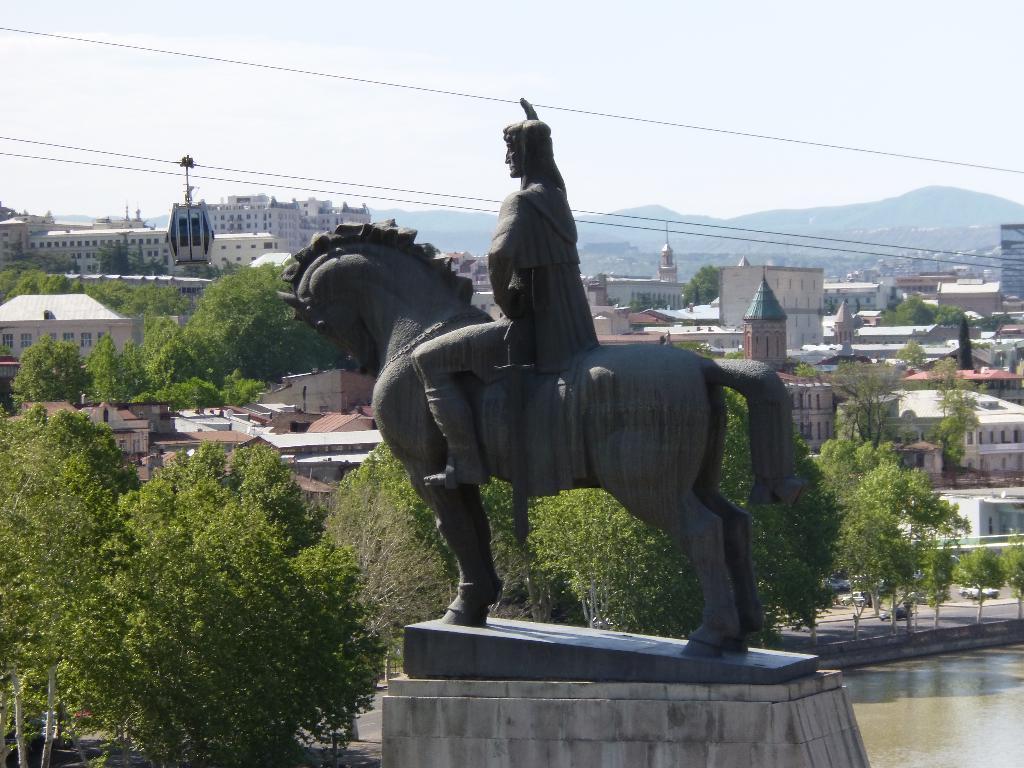In one or two sentences, can you explain what this image depicts? In this image we can see a statue, pedestal, water, motor vehicles on the road, trees, buildings, sheds, rope way, hills and sky with clouds. 